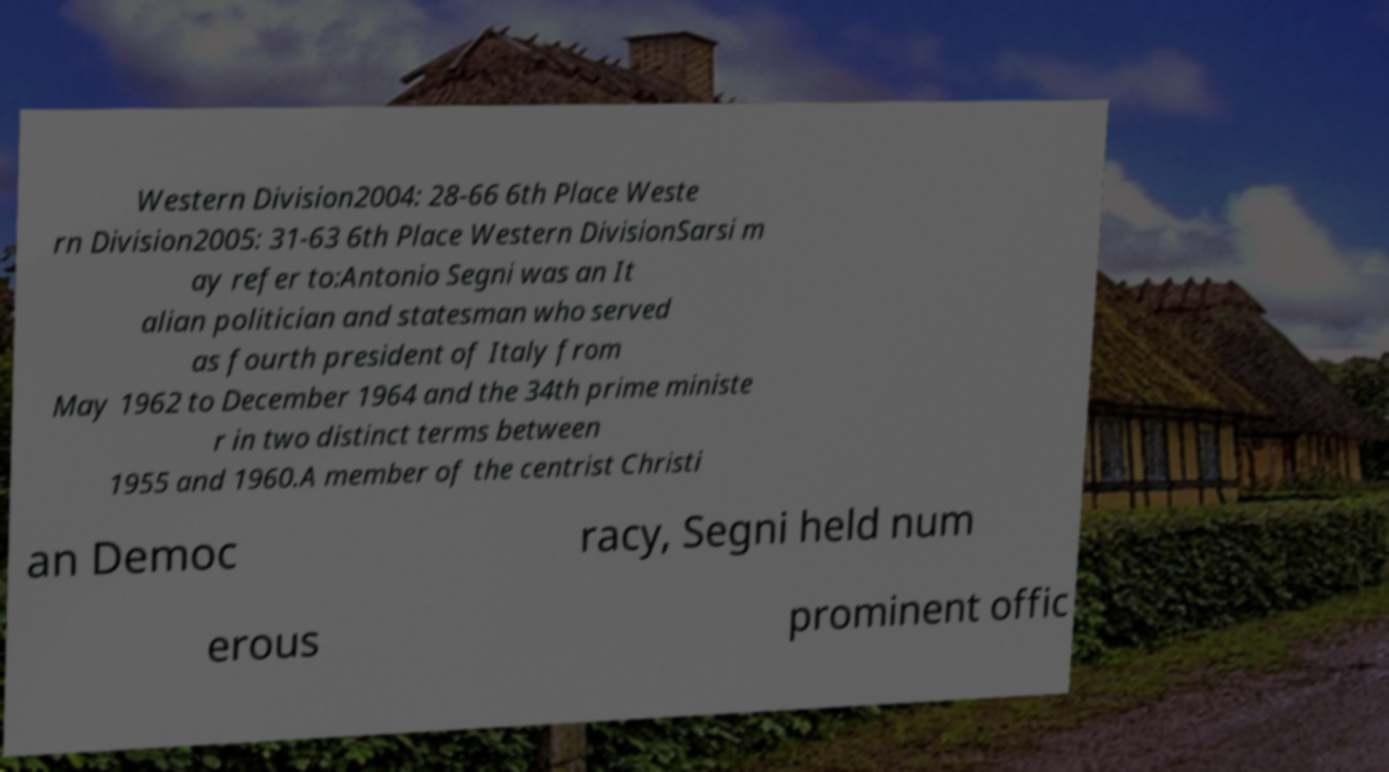What messages or text are displayed in this image? I need them in a readable, typed format. Western Division2004: 28-66 6th Place Weste rn Division2005: 31-63 6th Place Western DivisionSarsi m ay refer to:Antonio Segni was an It alian politician and statesman who served as fourth president of Italy from May 1962 to December 1964 and the 34th prime ministe r in two distinct terms between 1955 and 1960.A member of the centrist Christi an Democ racy, Segni held num erous prominent offic 